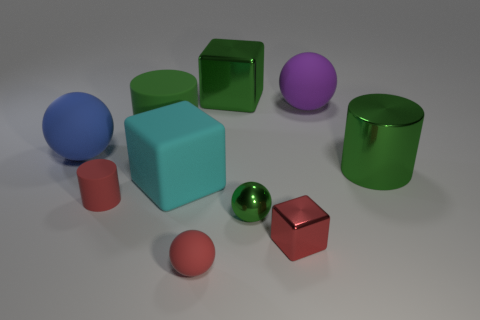What color is the matte ball that is on the right side of the small matte cylinder and to the left of the purple rubber sphere?
Make the answer very short. Red. What number of other things are the same shape as the green matte thing?
Ensure brevity in your answer.  2. Is the number of blue matte balls that are left of the red metal block less than the number of objects that are to the right of the large green block?
Provide a succinct answer. Yes. Does the big blue sphere have the same material as the red object to the left of the cyan thing?
Your answer should be very brief. Yes. Is the number of red rubber cylinders greater than the number of large blue metal cylinders?
Provide a succinct answer. Yes. There is a large green thing that is behind the big cylinder to the left of the green object behind the big purple thing; what is its shape?
Your response must be concise. Cube. Are the large sphere right of the big blue matte thing and the sphere that is to the left of the matte cube made of the same material?
Offer a very short reply. Yes. The big blue object that is the same material as the small cylinder is what shape?
Make the answer very short. Sphere. Is there any other thing that is the same color as the big matte block?
Keep it short and to the point. No. What number of small red matte things are there?
Offer a very short reply. 2. 